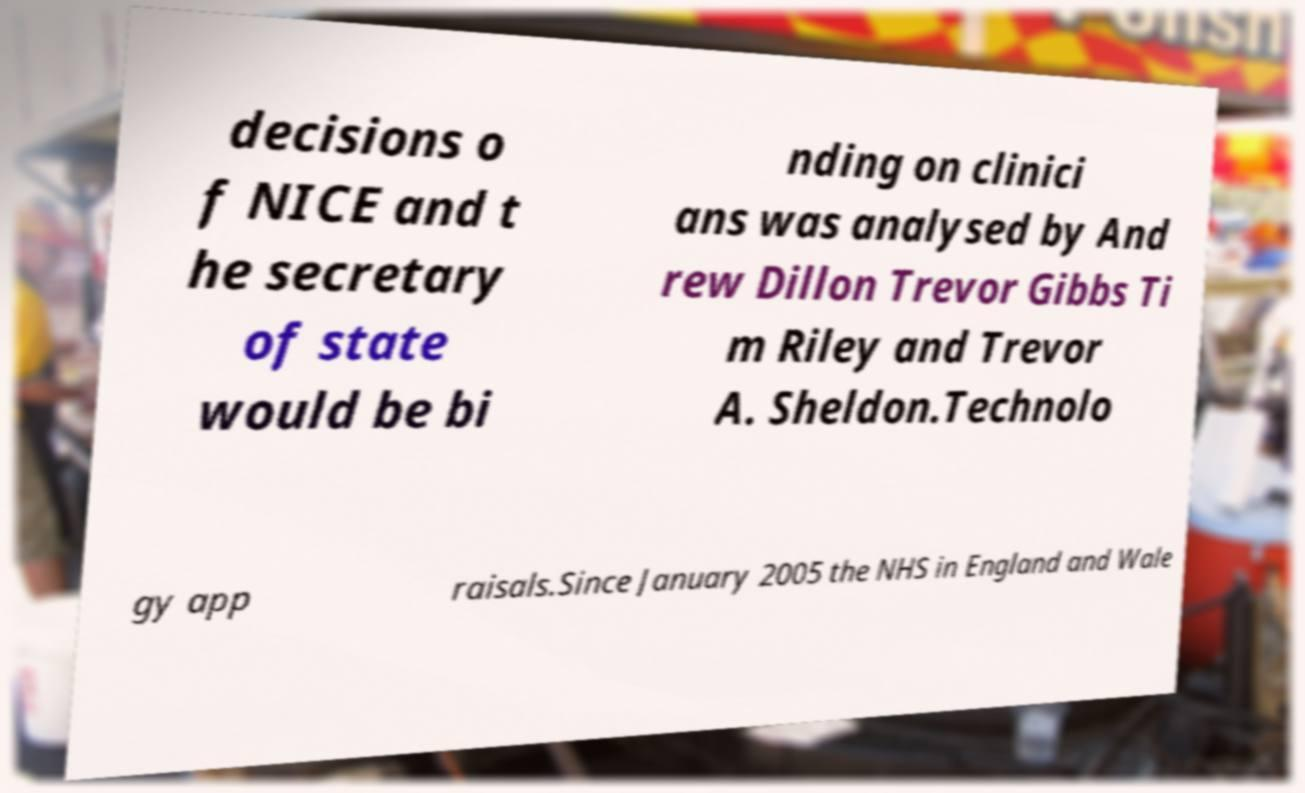Please read and relay the text visible in this image. What does it say? decisions o f NICE and t he secretary of state would be bi nding on clinici ans was analysed by And rew Dillon Trevor Gibbs Ti m Riley and Trevor A. Sheldon.Technolo gy app raisals.Since January 2005 the NHS in England and Wale 